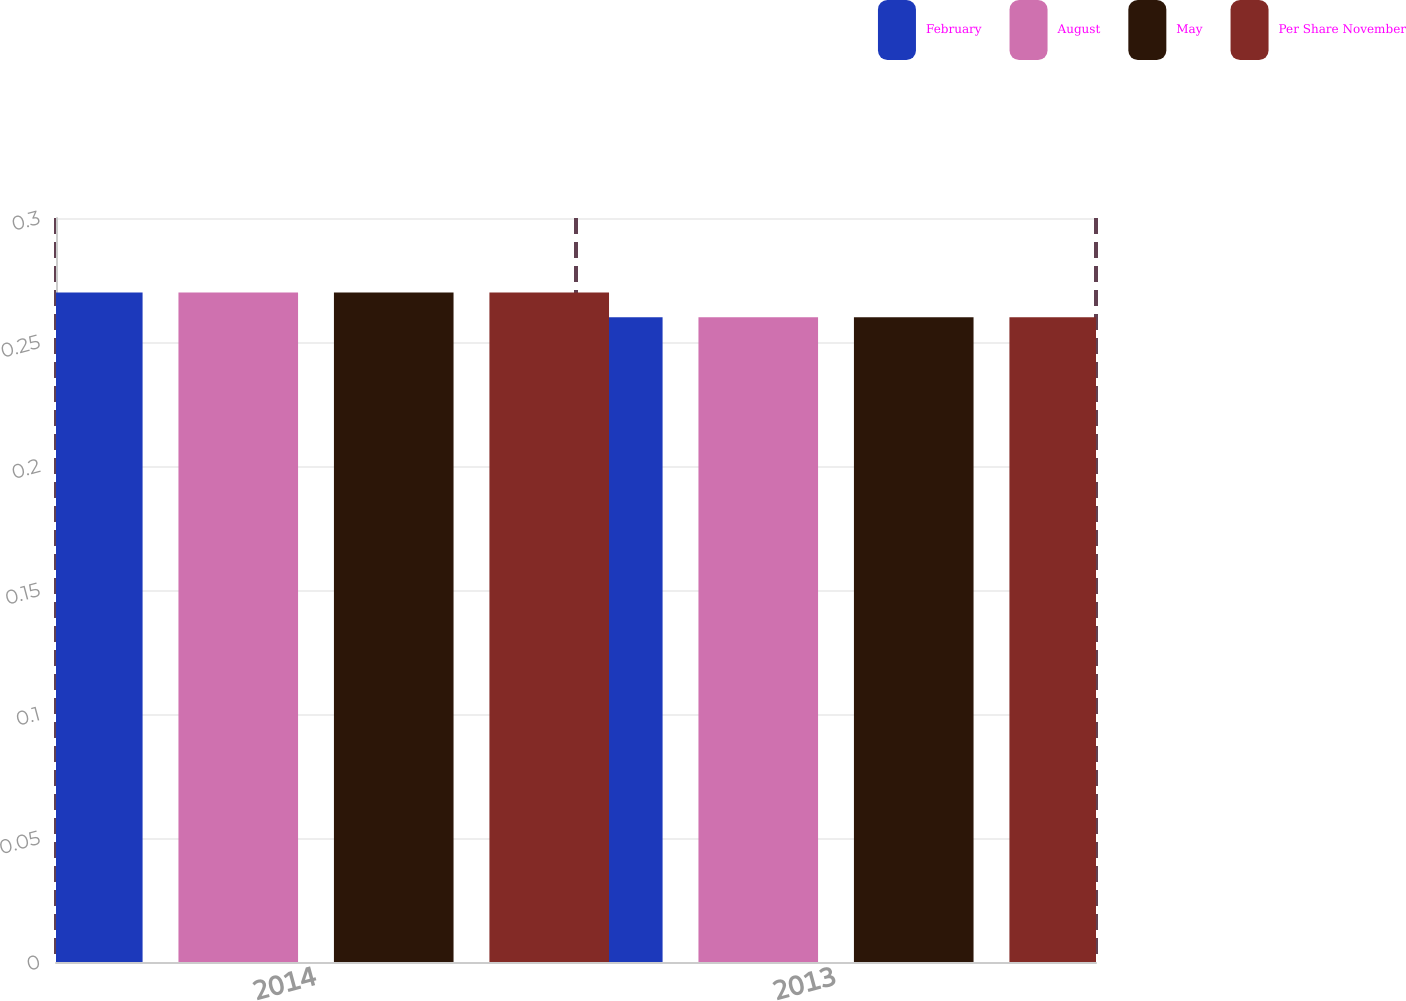Convert chart. <chart><loc_0><loc_0><loc_500><loc_500><stacked_bar_chart><ecel><fcel>2014<fcel>2013<nl><fcel>February<fcel>0.27<fcel>0.26<nl><fcel>August<fcel>0.27<fcel>0.26<nl><fcel>May<fcel>0.27<fcel>0.26<nl><fcel>Per Share November<fcel>0.27<fcel>0.26<nl></chart> 